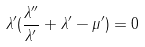Convert formula to latex. <formula><loc_0><loc_0><loc_500><loc_500>\lambda ^ { \prime } ( \frac { \lambda ^ { \prime \prime } } { \lambda ^ { \prime } } + \lambda ^ { \prime } - \mu ^ { \prime } ) = 0</formula> 